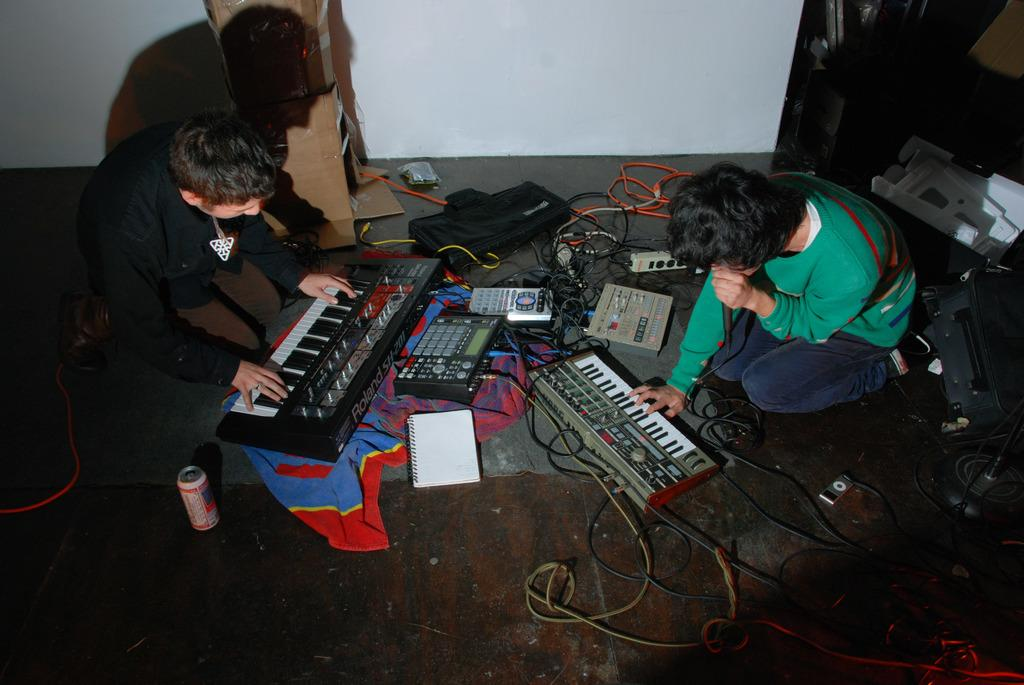How many people are sitting on the floor in the image? There are two persons sitting on the floor in the image. What else can be seen in the image besides the people sitting on the floor? There are musical instruments and a tin visible in the image. What is in the background of the image? There is a wall and cables visible in the background of the image. What religion do the people sitting on the floor practice in the image? There is no information about the religion of the people sitting on the floor in the image. 